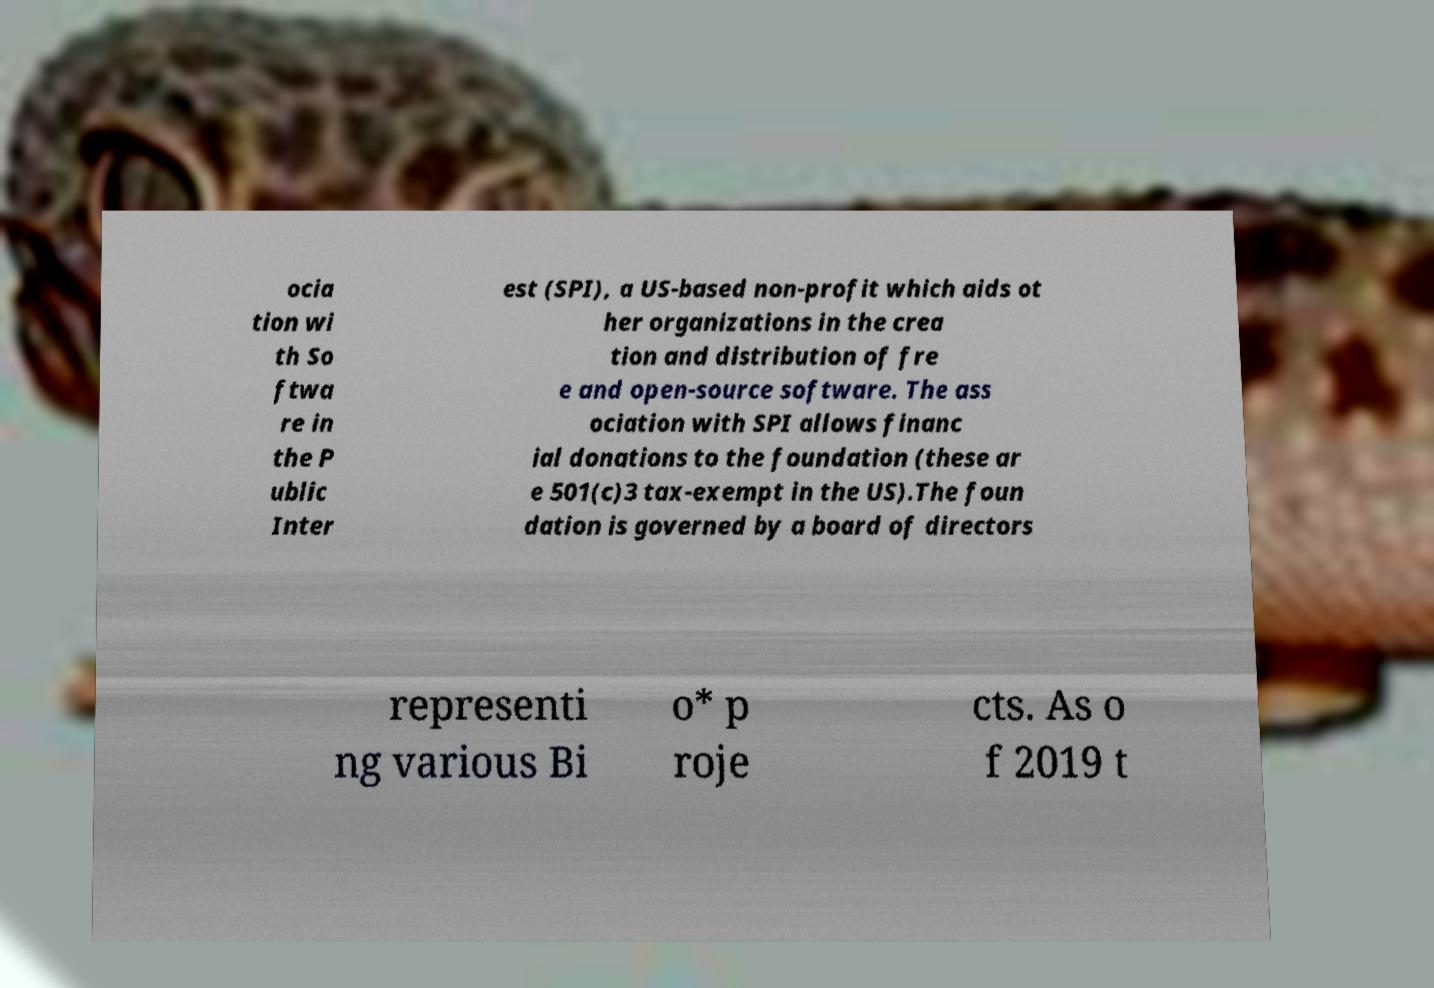Please read and relay the text visible in this image. What does it say? ocia tion wi th So ftwa re in the P ublic Inter est (SPI), a US-based non-profit which aids ot her organizations in the crea tion and distribution of fre e and open-source software. The ass ociation with SPI allows financ ial donations to the foundation (these ar e 501(c)3 tax-exempt in the US).The foun dation is governed by a board of directors representi ng various Bi o* p roje cts. As o f 2019 t 